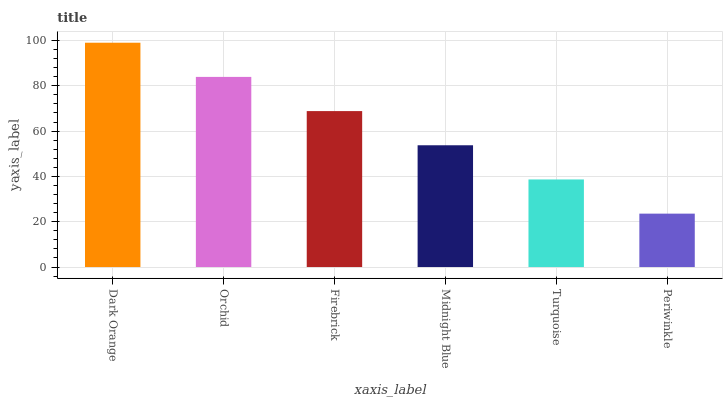Is Periwinkle the minimum?
Answer yes or no. Yes. Is Dark Orange the maximum?
Answer yes or no. Yes. Is Orchid the minimum?
Answer yes or no. No. Is Orchid the maximum?
Answer yes or no. No. Is Dark Orange greater than Orchid?
Answer yes or no. Yes. Is Orchid less than Dark Orange?
Answer yes or no. Yes. Is Orchid greater than Dark Orange?
Answer yes or no. No. Is Dark Orange less than Orchid?
Answer yes or no. No. Is Firebrick the high median?
Answer yes or no. Yes. Is Midnight Blue the low median?
Answer yes or no. Yes. Is Dark Orange the high median?
Answer yes or no. No. Is Turquoise the low median?
Answer yes or no. No. 